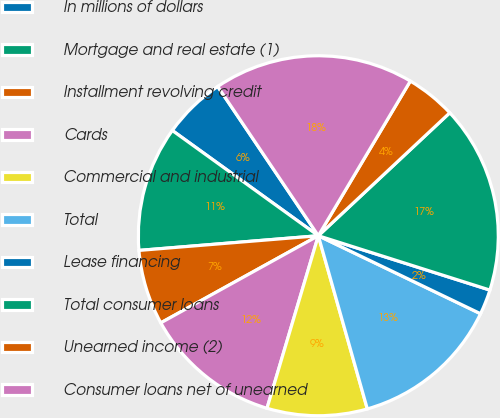Convert chart. <chart><loc_0><loc_0><loc_500><loc_500><pie_chart><fcel>In millions of dollars<fcel>Mortgage and real estate (1)<fcel>Installment revolving credit<fcel>Cards<fcel>Commercial and industrial<fcel>Total<fcel>Lease financing<fcel>Total consumer loans<fcel>Unearned income (2)<fcel>Consumer loans net of unearned<nl><fcel>5.62%<fcel>11.24%<fcel>6.74%<fcel>12.36%<fcel>8.99%<fcel>13.48%<fcel>2.25%<fcel>16.85%<fcel>4.49%<fcel>17.98%<nl></chart> 